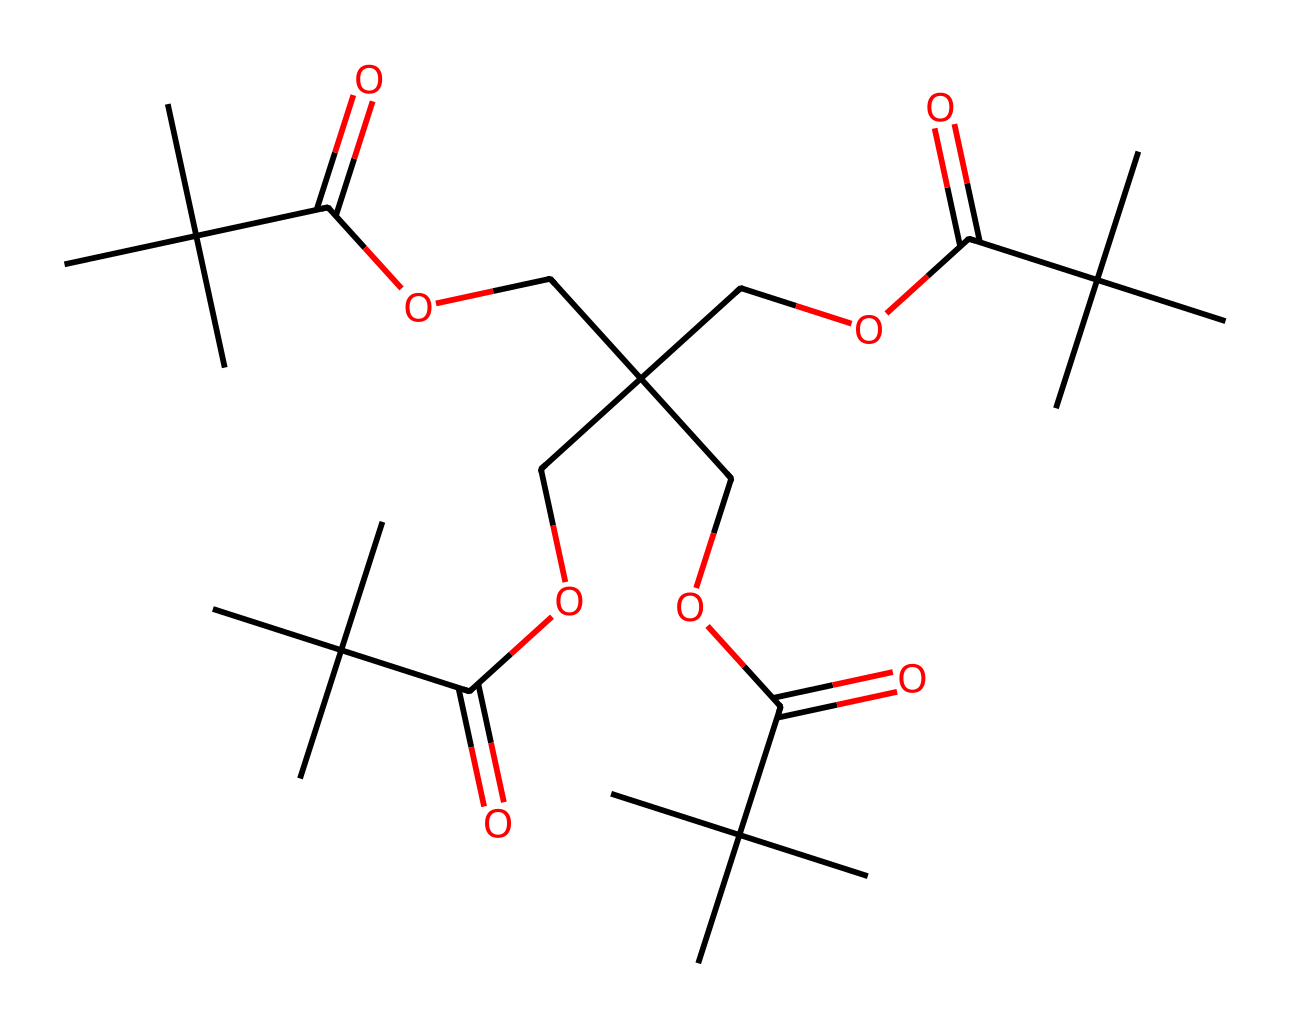What is the functional group present in this molecule? The molecule has a carboxylic acid functional group (-COOH), as indicated by the presence of the carbonyl (C=O) and hydroxyl (–OH) groups connected to a carbon atom.
Answer: carboxylic acid How many carbon atoms are present in this structure? By counting each carbon atom in the provided SMILES notation, we can determine that there are 21 carbon atoms in total in the molecule.
Answer: 21 What is the molecular weight of the compound represented by the SMILES? To calculate the molecular weight, we evaluate the contributions of each atom type using its standard atomic weights: C=12, H=1, O=16. Calculating those gives a molecular weight of approximately 402.5 g/mol.
Answer: 402.5 What type of chemical is this compound classified as? Since this is a photoresist with specific properties for application on materials, particularly those requiring resistance to sweat, it can be classified as a polymeric compound.
Answer: polymeric How many ester groups are present in this molecule? The structure shows multiple connections indicating ester linkages, and by analyzing the SMILES, we find that there are 6 ester groups present in the molecular structure.
Answer: 6 Does this molecule have a symmetrical structure? The arrangement of the carbon chains and substituents in the SMILES suggests a symmetrical distribution of the functional groups, leading to the conclusion that this molecule is symmetrical in its layout.
Answer: yes Is this photoresist likely to be hydrophilic or hydrophobic? The presence of ester and alkyl groups suggests that this compound will have hydrophobic characteristics, meaning it resists water solubility.
Answer: hydrophobic 